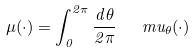<formula> <loc_0><loc_0><loc_500><loc_500>\mu ( \cdot ) = \int _ { 0 } ^ { 2 \pi } \frac { d \theta } { 2 \pi } \ \ \ m u _ { \theta } ( \cdot )</formula> 